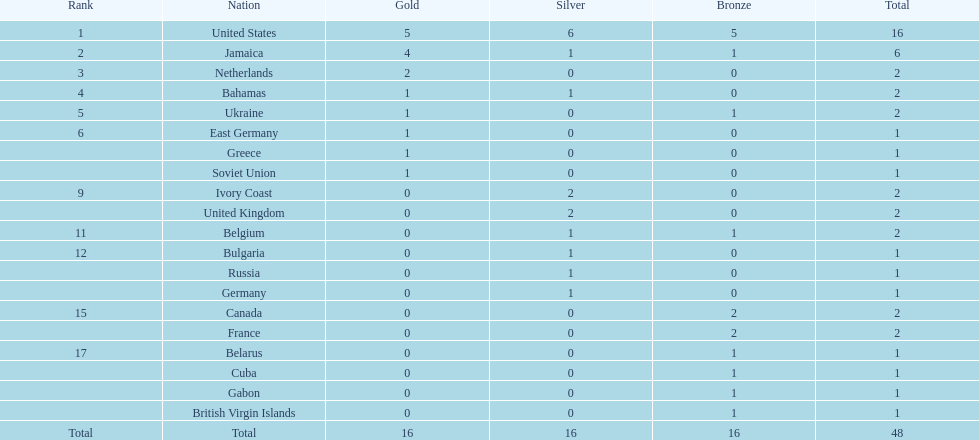What is the total number of gold medals won by jamaica? 4. 